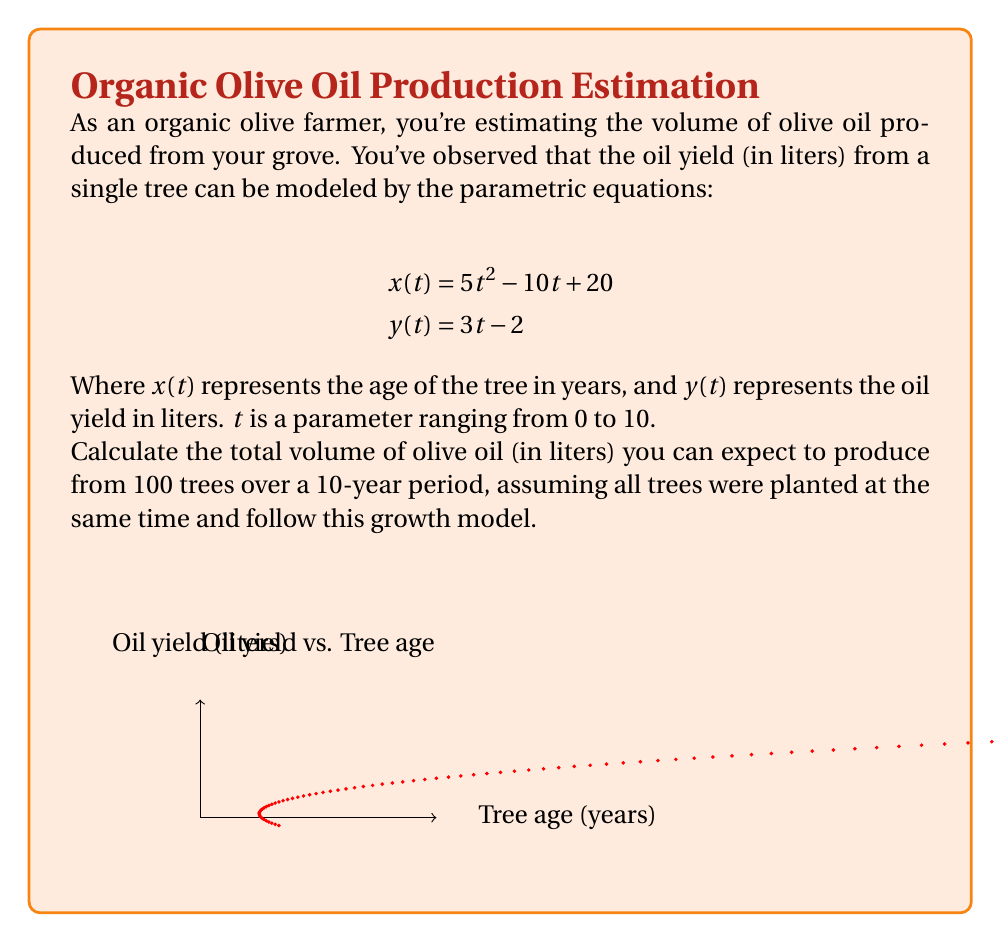Provide a solution to this math problem. To solve this problem, we'll follow these steps:

1) First, we need to find the total oil yield for a single tree over 10 years.

2) The parametric equations given are:
   $$x(t) = 5t^2 - 10t + 20$$
   $$y(t) = 3t - 2$$

3) We need to find $y$ when $t = 10$ (representing 10 years):
   $$y(10) = 3(10) - 2 = 28$$

4) This means that after 10 years, a single tree produces 28 liters of olive oil.

5) However, this is the cumulative production over 10 years, not the average yearly production.

6) To find the total production over 10 years for 100 trees:
   $$\text{Total Production} = 28 \text{ liters} \times 100 \text{ trees} = 2800 \text{ liters}$$

Therefore, you can expect to produce 2800 liters of olive oil from 100 trees over a 10-year period.
Answer: 2800 liters 